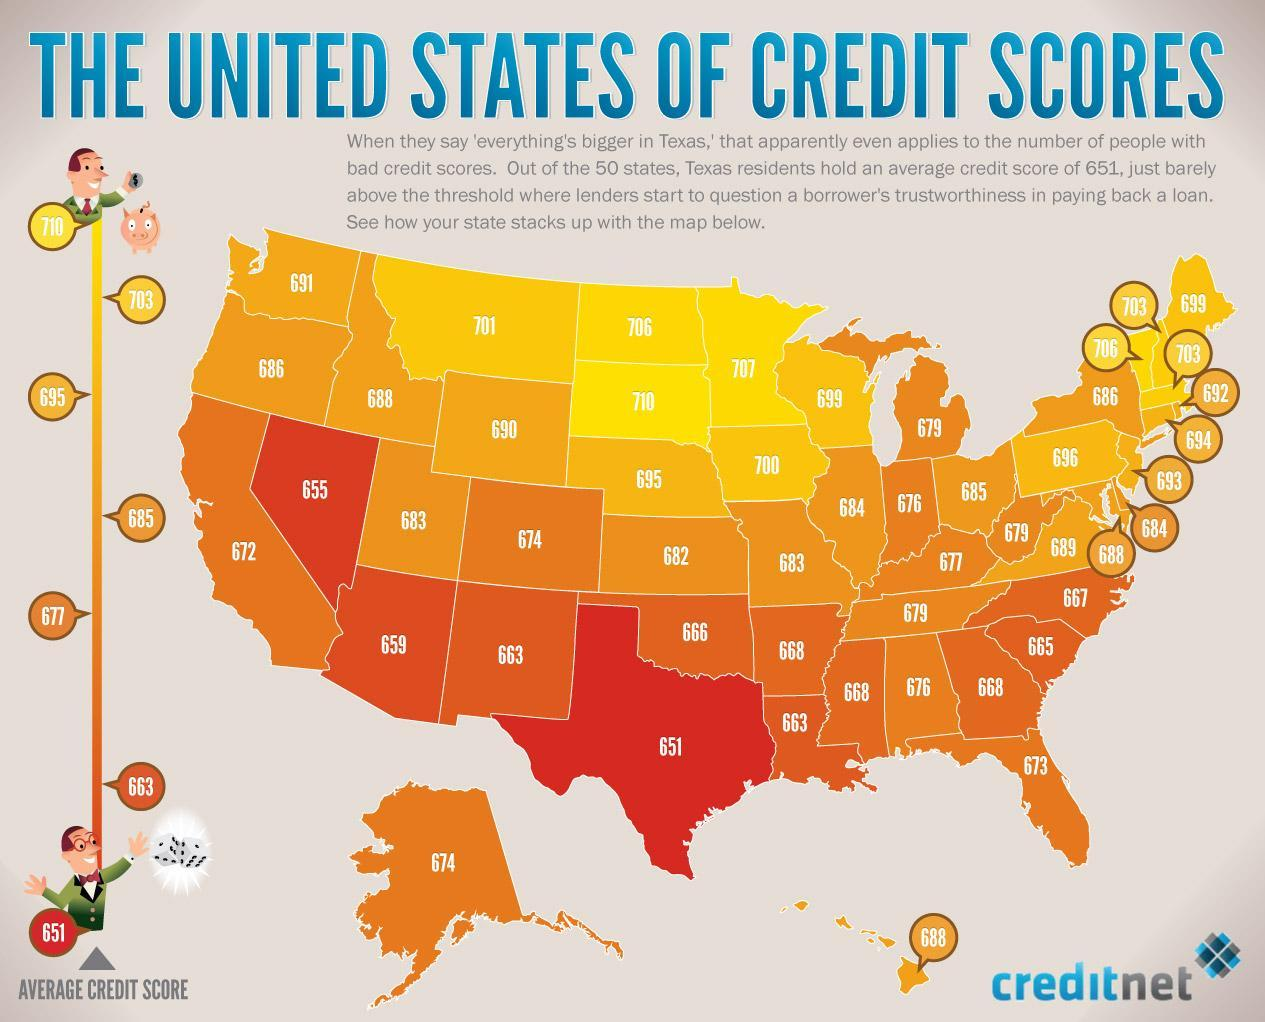How many states have credit score above 700?
Answer the question with a short phrase. 8 The states in which region have comparatively better credit score - northern or southern? northern What is the second highest credit score? 707 What is the second lowest credit score as per the image? 655 